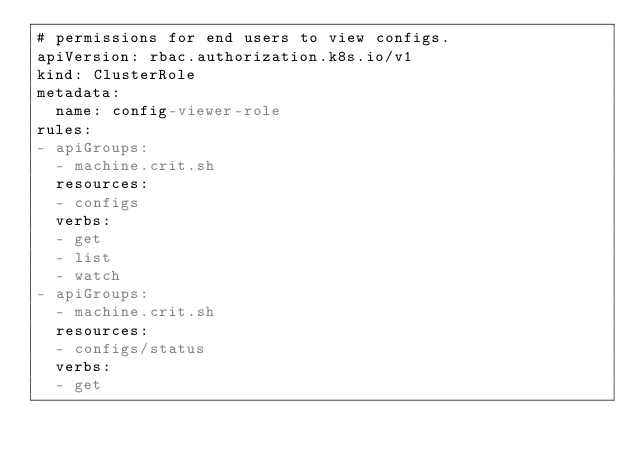<code> <loc_0><loc_0><loc_500><loc_500><_YAML_># permissions for end users to view configs.
apiVersion: rbac.authorization.k8s.io/v1
kind: ClusterRole
metadata:
  name: config-viewer-role
rules:
- apiGroups:
  - machine.crit.sh
  resources:
  - configs
  verbs:
  - get
  - list
  - watch
- apiGroups:
  - machine.crit.sh
  resources:
  - configs/status
  verbs:
  - get
</code> 